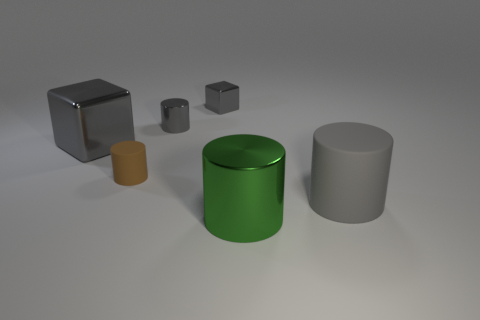Are there any brown shiny cylinders that have the same size as the gray shiny cylinder?
Provide a succinct answer. No. There is a gray cylinder to the left of the gray rubber cylinder; is its size the same as the small brown cylinder?
Provide a short and direct response. Yes. The metal object that is in front of the small gray shiny cylinder and behind the gray matte cylinder has what shape?
Your response must be concise. Cube. Are there more large shiny cubes that are in front of the big gray rubber thing than tiny gray metal cubes?
Ensure brevity in your answer.  No. There is a green cylinder that is made of the same material as the tiny cube; what is its size?
Offer a terse response. Large. How many tiny cubes are the same color as the small metal cylinder?
Your response must be concise. 1. Is the color of the matte cylinder that is on the right side of the large green thing the same as the tiny matte cylinder?
Your answer should be very brief. No. Is the number of big green cylinders that are right of the gray matte thing the same as the number of big gray matte cylinders in front of the big green metal cylinder?
Ensure brevity in your answer.  Yes. Is there anything else that has the same material as the tiny block?
Your response must be concise. Yes. There is a object that is in front of the big gray cylinder; what color is it?
Your answer should be very brief. Green. 